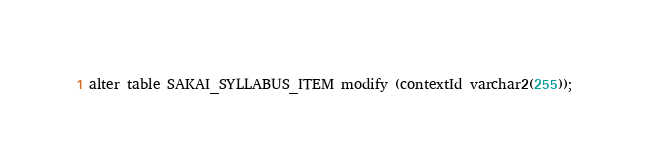Convert code to text. <code><loc_0><loc_0><loc_500><loc_500><_SQL_>alter table SAKAI_SYLLABUS_ITEM modify (contextId varchar2(255));</code> 